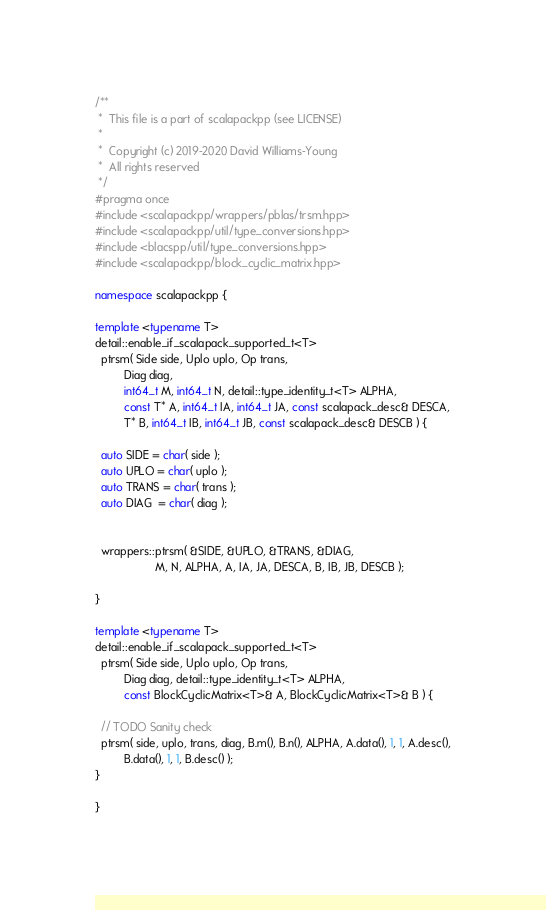Convert code to text. <code><loc_0><loc_0><loc_500><loc_500><_C++_>/**
 *  This file is a part of scalapackpp (see LICENSE)
 *
 *  Copyright (c) 2019-2020 David Williams-Young
 *  All rights reserved
 */
#pragma once
#include <scalapackpp/wrappers/pblas/trsm.hpp>
#include <scalapackpp/util/type_conversions.hpp>
#include <blacspp/util/type_conversions.hpp>
#include <scalapackpp/block_cyclic_matrix.hpp>

namespace scalapackpp {

template <typename T>
detail::enable_if_scalapack_supported_t<T>
  ptrsm( Side side, Uplo uplo, Op trans, 
         Diag diag,
         int64_t M, int64_t N, detail::type_identity_t<T> ALPHA, 
         const T* A, int64_t IA, int64_t JA, const scalapack_desc& DESCA,
         T* B, int64_t IB, int64_t JB, const scalapack_desc& DESCB ) {

  auto SIDE = char( side );
  auto UPLO = char( uplo );
  auto TRANS = char( trans );
  auto DIAG  = char( diag );


  wrappers::ptrsm( &SIDE, &UPLO, &TRANS, &DIAG,
                   M, N, ALPHA, A, IA, JA, DESCA, B, IB, JB, DESCB );

}

template <typename T>
detail::enable_if_scalapack_supported_t<T>
  ptrsm( Side side, Uplo uplo, Op trans, 
         Diag diag, detail::type_identity_t<T> ALPHA, 
         const BlockCyclicMatrix<T>& A, BlockCyclicMatrix<T>& B ) {

  // TODO Sanity check
  ptrsm( side, uplo, trans, diag, B.m(), B.n(), ALPHA, A.data(), 1, 1, A.desc(),
         B.data(), 1, 1, B.desc() );
}

}
</code> 